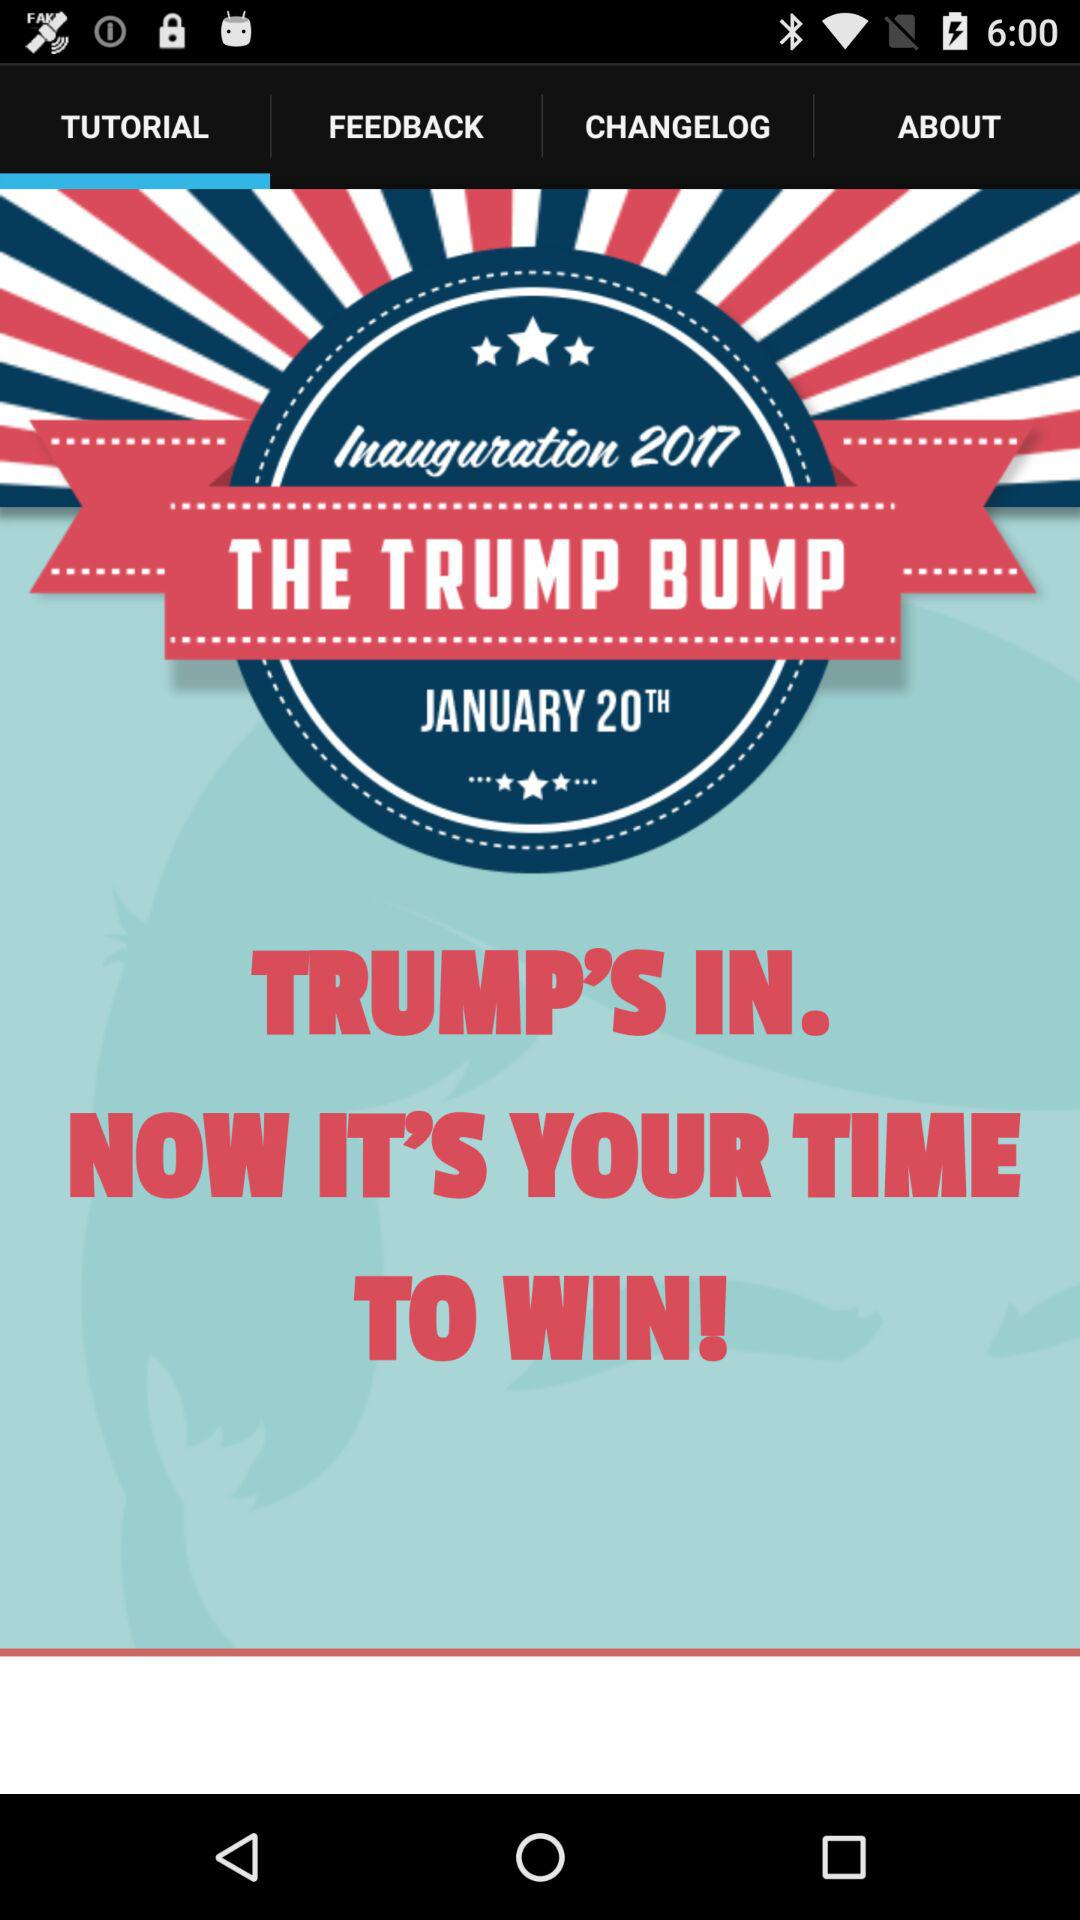What is the year? The year is 2017. 